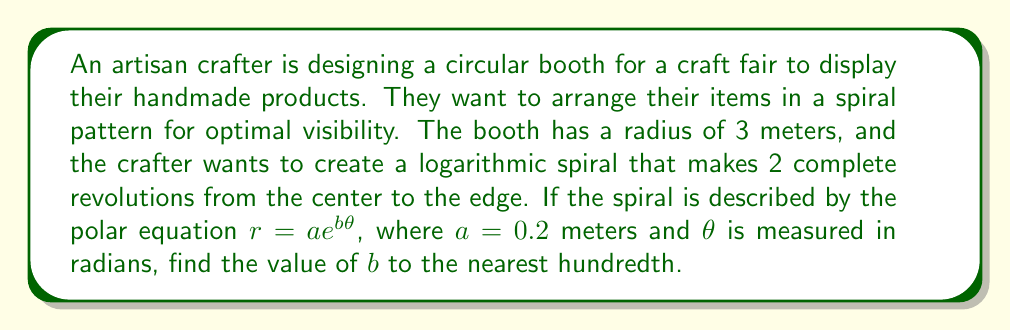Provide a solution to this math problem. To solve this problem, we'll follow these steps:

1) In a logarithmic spiral, the equation is given by $r = ae^{b\theta}$, where:
   - $r$ is the radius at any point
   - $a$ is the starting radius (when $\theta = 0$)
   - $b$ is the growth rate of the spiral
   - $\theta$ is the angle in radians

2) We know that:
   - The spiral starts at $r = 0.2$ meters (given $a = 0.2$)
   - The spiral ends at $r = 3$ meters (the booth radius)
   - The spiral makes 2 complete revolutions, so $\theta = 4\pi$ radians

3) We can set up the equation:
   $3 = 0.2e^{b(4\pi)}$

4) To solve for $b$, let's take the natural log of both sides:
   $\ln(3) = \ln(0.2e^{b(4\pi)})$

5) Using the properties of logarithms:
   $\ln(3) = \ln(0.2) + b(4\pi)$

6) Subtract $\ln(0.2)$ from both sides:
   $\ln(3) - \ln(0.2) = b(4\pi)$

7) Divide both sides by $4\pi$:
   $b = \frac{\ln(3) - \ln(0.2)}{4\pi}$

8) Calculate the value:
   $b = \frac{1.0986 - (-1.6094)}{12.5664} \approx 0.2157$

9) Rounding to the nearest hundredth:
   $b \approx 0.22$
Answer: $b \approx 0.22$ 